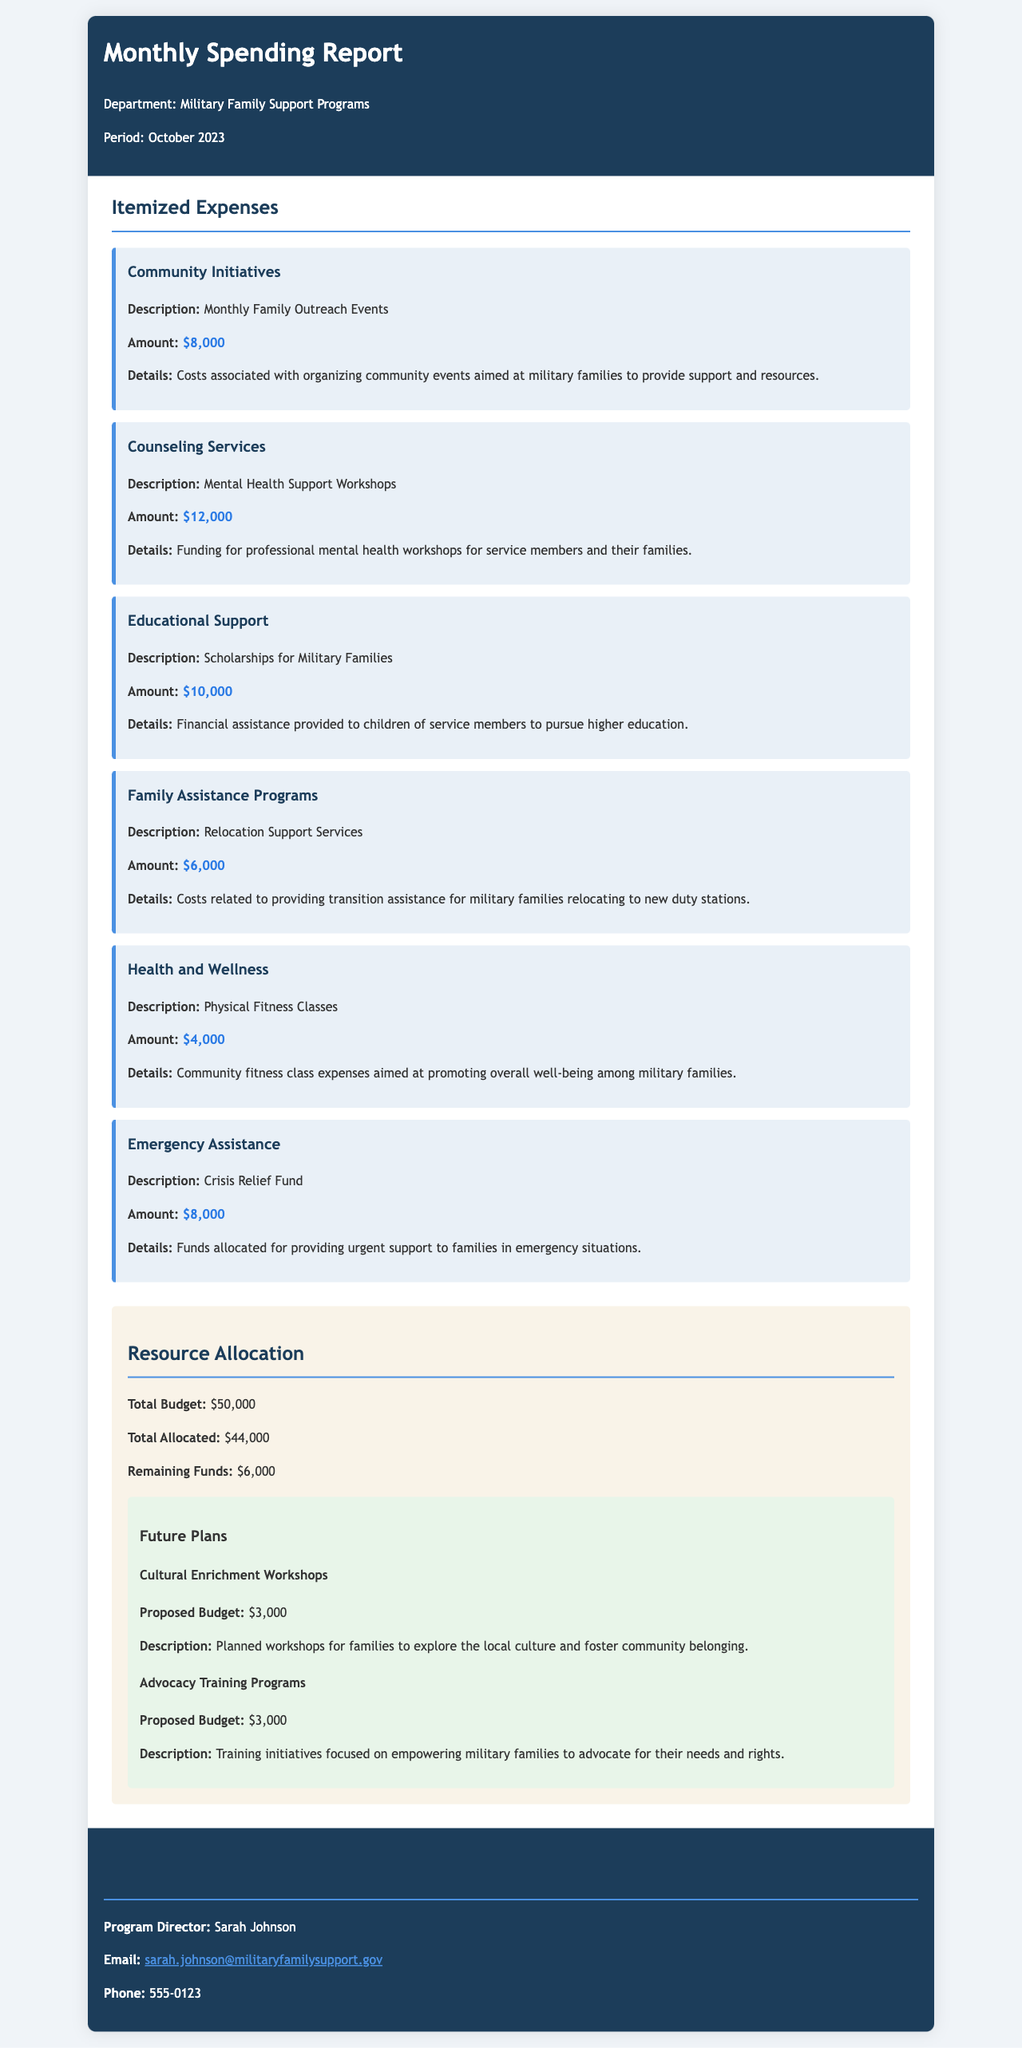What is the total allocated budget for the programs? The total allocated budget is the sum of all itemized expenses, which is $44,000.
Answer: $44,000 Who is the Program Director? The name of the Program Director is mentioned in the contact information section.
Answer: Sarah Johnson What is the amount allocated for Mental Health Support Workshops? The amount is specified under the Counseling Services expense.
Answer: $12,000 What is the remaining budget after expenses? The remaining budget is calculated as the difference between the total budget and the total allocated amount.
Answer: $6,000 What is one of the future plans listed in the document? Future plans include workshops and training initiatives proposed for upcoming events.
Answer: Cultural Enrichment Workshops What is the proposed budget for Advocacy Training Programs? The proposed budget is specified in the future plans section of the document.
Answer: $3,000 What is the total budget for Military Family Support Programs? The total budget is stated in the resource allocation section.
Answer: $50,000 Which service has the least allocated amount? By comparing all the itemized expenses, the service with the least allocation is identified.
Answer: Physical Fitness Classes 